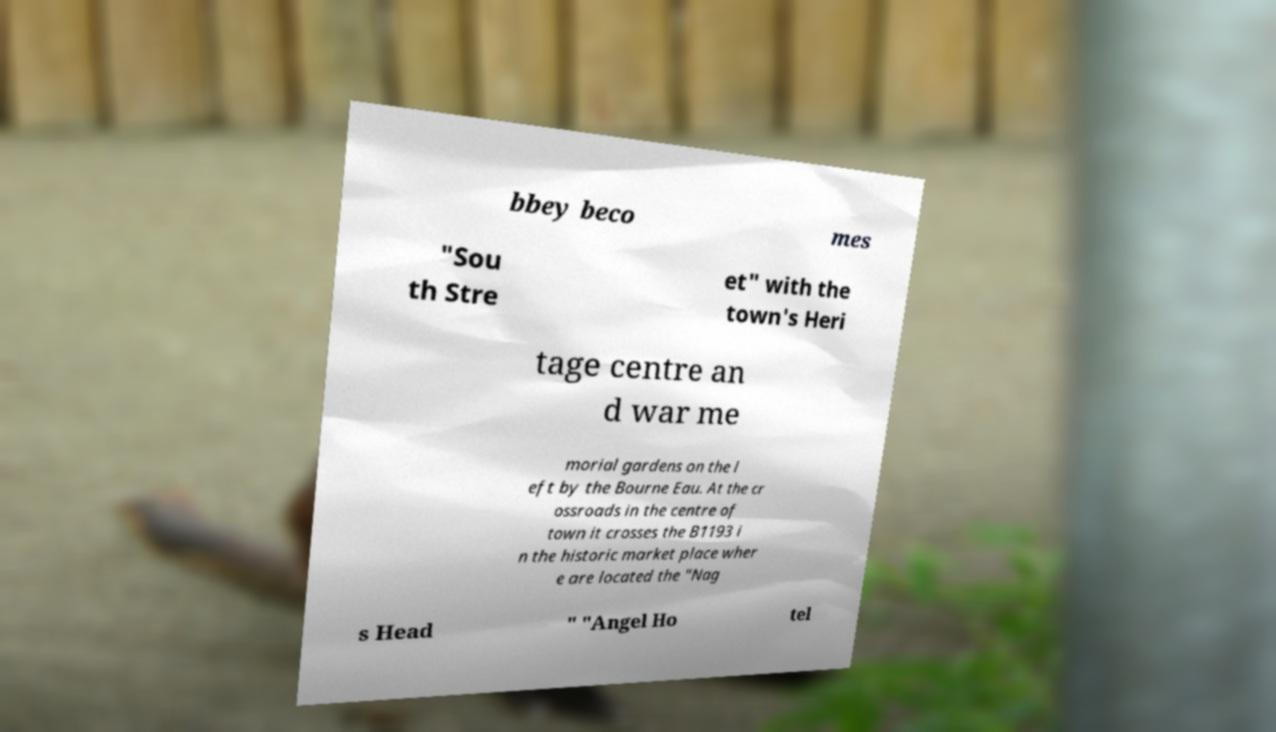Could you assist in decoding the text presented in this image and type it out clearly? bbey beco mes "Sou th Stre et" with the town's Heri tage centre an d war me morial gardens on the l eft by the Bourne Eau. At the cr ossroads in the centre of town it crosses the B1193 i n the historic market place wher e are located the "Nag s Head " "Angel Ho tel 